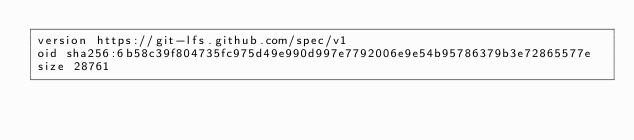<code> <loc_0><loc_0><loc_500><loc_500><_HTML_>version https://git-lfs.github.com/spec/v1
oid sha256:6b58c39f804735fc975d49e990d997e7792006e9e54b95786379b3e72865577e
size 28761
</code> 